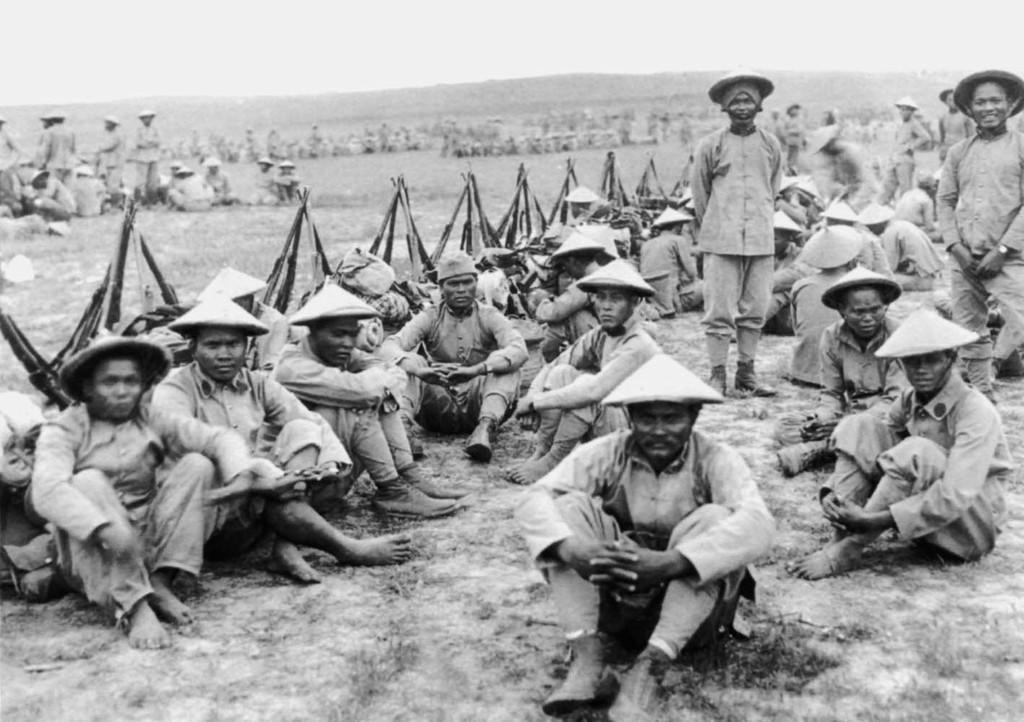Describe this image in one or two sentences. In this picture there are people those who are sitting and some are standing in the center of the image, there are guns with them and there are other people in the background area of the image. 